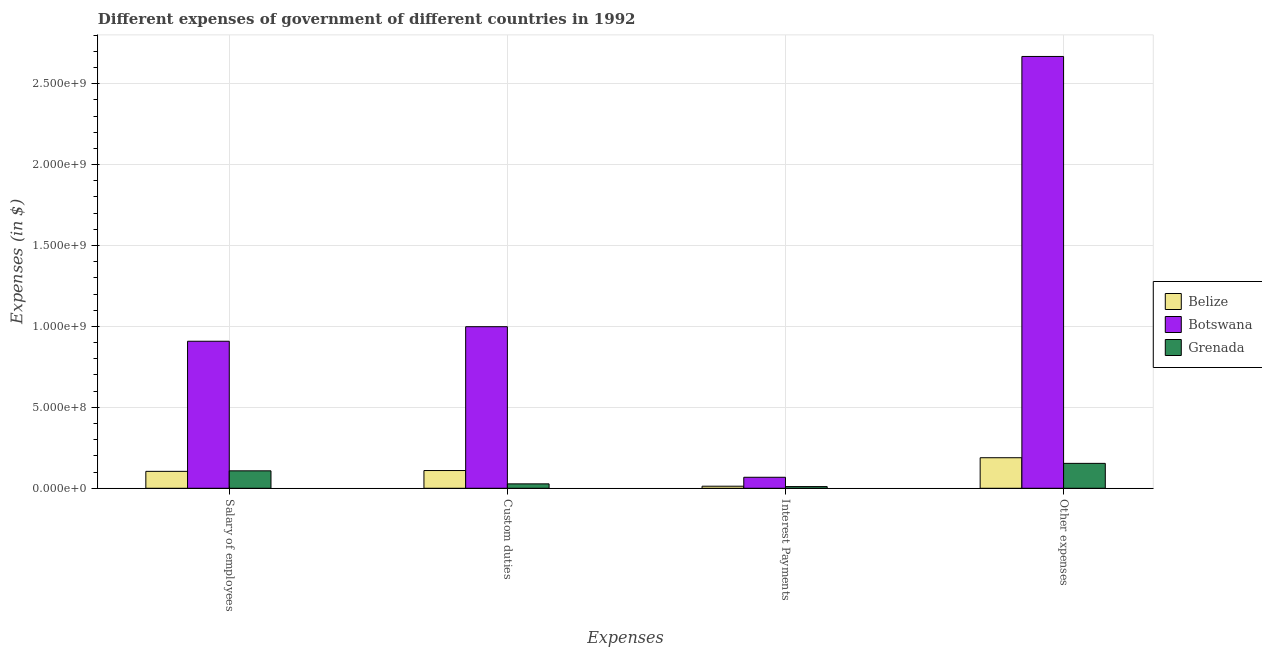How many different coloured bars are there?
Provide a short and direct response. 3. How many groups of bars are there?
Your answer should be compact. 4. How many bars are there on the 2nd tick from the left?
Your answer should be very brief. 3. What is the label of the 3rd group of bars from the left?
Your response must be concise. Interest Payments. What is the amount spent on salary of employees in Belize?
Provide a succinct answer. 1.05e+08. Across all countries, what is the maximum amount spent on custom duties?
Offer a terse response. 9.98e+08. Across all countries, what is the minimum amount spent on other expenses?
Provide a succinct answer. 1.54e+08. In which country was the amount spent on other expenses maximum?
Provide a short and direct response. Botswana. In which country was the amount spent on salary of employees minimum?
Offer a very short reply. Belize. What is the total amount spent on salary of employees in the graph?
Make the answer very short. 1.12e+09. What is the difference between the amount spent on custom duties in Grenada and that in Botswana?
Your answer should be compact. -9.71e+08. What is the difference between the amount spent on custom duties in Botswana and the amount spent on other expenses in Grenada?
Your response must be concise. 8.44e+08. What is the average amount spent on interest payments per country?
Your answer should be very brief. 3.04e+07. What is the difference between the amount spent on custom duties and amount spent on other expenses in Grenada?
Offer a terse response. -1.27e+08. What is the ratio of the amount spent on other expenses in Belize to that in Botswana?
Give a very brief answer. 0.07. Is the amount spent on salary of employees in Botswana less than that in Belize?
Offer a very short reply. No. What is the difference between the highest and the second highest amount spent on custom duties?
Your answer should be compact. 8.89e+08. What is the difference between the highest and the lowest amount spent on salary of employees?
Your answer should be very brief. 8.04e+08. Is the sum of the amount spent on salary of employees in Botswana and Grenada greater than the maximum amount spent on custom duties across all countries?
Your answer should be very brief. Yes. Is it the case that in every country, the sum of the amount spent on custom duties and amount spent on other expenses is greater than the sum of amount spent on interest payments and amount spent on salary of employees?
Your answer should be very brief. No. What does the 1st bar from the left in Custom duties represents?
Provide a short and direct response. Belize. What does the 3rd bar from the right in Custom duties represents?
Keep it short and to the point. Belize. Is it the case that in every country, the sum of the amount spent on salary of employees and amount spent on custom duties is greater than the amount spent on interest payments?
Give a very brief answer. Yes. How many bars are there?
Offer a terse response. 12. What is the difference between two consecutive major ticks on the Y-axis?
Ensure brevity in your answer.  5.00e+08. What is the title of the graph?
Your answer should be compact. Different expenses of government of different countries in 1992. Does "Colombia" appear as one of the legend labels in the graph?
Give a very brief answer. No. What is the label or title of the X-axis?
Make the answer very short. Expenses. What is the label or title of the Y-axis?
Provide a succinct answer. Expenses (in $). What is the Expenses (in $) in Belize in Salary of employees?
Keep it short and to the point. 1.05e+08. What is the Expenses (in $) of Botswana in Salary of employees?
Offer a very short reply. 9.08e+08. What is the Expenses (in $) in Grenada in Salary of employees?
Give a very brief answer. 1.08e+08. What is the Expenses (in $) of Belize in Custom duties?
Give a very brief answer. 1.10e+08. What is the Expenses (in $) in Botswana in Custom duties?
Your answer should be very brief. 9.98e+08. What is the Expenses (in $) of Grenada in Custom duties?
Ensure brevity in your answer.  2.73e+07. What is the Expenses (in $) of Belize in Interest Payments?
Provide a succinct answer. 1.28e+07. What is the Expenses (in $) of Botswana in Interest Payments?
Your response must be concise. 6.80e+07. What is the Expenses (in $) in Grenada in Interest Payments?
Give a very brief answer. 1.04e+07. What is the Expenses (in $) of Belize in Other expenses?
Offer a very short reply. 1.89e+08. What is the Expenses (in $) of Botswana in Other expenses?
Offer a terse response. 2.67e+09. What is the Expenses (in $) of Grenada in Other expenses?
Offer a very short reply. 1.54e+08. Across all Expenses, what is the maximum Expenses (in $) of Belize?
Make the answer very short. 1.89e+08. Across all Expenses, what is the maximum Expenses (in $) in Botswana?
Offer a terse response. 2.67e+09. Across all Expenses, what is the maximum Expenses (in $) in Grenada?
Provide a succinct answer. 1.54e+08. Across all Expenses, what is the minimum Expenses (in $) of Belize?
Offer a very short reply. 1.28e+07. Across all Expenses, what is the minimum Expenses (in $) of Botswana?
Ensure brevity in your answer.  6.80e+07. Across all Expenses, what is the minimum Expenses (in $) in Grenada?
Give a very brief answer. 1.04e+07. What is the total Expenses (in $) of Belize in the graph?
Provide a short and direct response. 4.16e+08. What is the total Expenses (in $) in Botswana in the graph?
Offer a terse response. 4.64e+09. What is the total Expenses (in $) of Grenada in the graph?
Provide a succinct answer. 3.00e+08. What is the difference between the Expenses (in $) of Belize in Salary of employees and that in Custom duties?
Make the answer very short. -4.97e+06. What is the difference between the Expenses (in $) of Botswana in Salary of employees and that in Custom duties?
Provide a succinct answer. -8.99e+07. What is the difference between the Expenses (in $) in Grenada in Salary of employees and that in Custom duties?
Your answer should be very brief. 8.05e+07. What is the difference between the Expenses (in $) of Belize in Salary of employees and that in Interest Payments?
Provide a short and direct response. 9.19e+07. What is the difference between the Expenses (in $) in Botswana in Salary of employees and that in Interest Payments?
Make the answer very short. 8.40e+08. What is the difference between the Expenses (in $) in Grenada in Salary of employees and that in Interest Payments?
Offer a terse response. 9.74e+07. What is the difference between the Expenses (in $) of Belize in Salary of employees and that in Other expenses?
Offer a very short reply. -8.41e+07. What is the difference between the Expenses (in $) in Botswana in Salary of employees and that in Other expenses?
Ensure brevity in your answer.  -1.76e+09. What is the difference between the Expenses (in $) in Grenada in Salary of employees and that in Other expenses?
Your response must be concise. -4.62e+07. What is the difference between the Expenses (in $) in Belize in Custom duties and that in Interest Payments?
Ensure brevity in your answer.  9.68e+07. What is the difference between the Expenses (in $) of Botswana in Custom duties and that in Interest Payments?
Offer a very short reply. 9.30e+08. What is the difference between the Expenses (in $) in Grenada in Custom duties and that in Interest Payments?
Your response must be concise. 1.68e+07. What is the difference between the Expenses (in $) in Belize in Custom duties and that in Other expenses?
Offer a very short reply. -7.92e+07. What is the difference between the Expenses (in $) in Botswana in Custom duties and that in Other expenses?
Offer a terse response. -1.67e+09. What is the difference between the Expenses (in $) in Grenada in Custom duties and that in Other expenses?
Your answer should be compact. -1.27e+08. What is the difference between the Expenses (in $) of Belize in Interest Payments and that in Other expenses?
Provide a short and direct response. -1.76e+08. What is the difference between the Expenses (in $) in Botswana in Interest Payments and that in Other expenses?
Keep it short and to the point. -2.60e+09. What is the difference between the Expenses (in $) of Grenada in Interest Payments and that in Other expenses?
Your answer should be very brief. -1.44e+08. What is the difference between the Expenses (in $) in Belize in Salary of employees and the Expenses (in $) in Botswana in Custom duties?
Keep it short and to the point. -8.94e+08. What is the difference between the Expenses (in $) of Belize in Salary of employees and the Expenses (in $) of Grenada in Custom duties?
Offer a terse response. 7.73e+07. What is the difference between the Expenses (in $) in Botswana in Salary of employees and the Expenses (in $) in Grenada in Custom duties?
Offer a terse response. 8.81e+08. What is the difference between the Expenses (in $) in Belize in Salary of employees and the Expenses (in $) in Botswana in Interest Payments?
Your response must be concise. 3.66e+07. What is the difference between the Expenses (in $) of Belize in Salary of employees and the Expenses (in $) of Grenada in Interest Payments?
Ensure brevity in your answer.  9.42e+07. What is the difference between the Expenses (in $) of Botswana in Salary of employees and the Expenses (in $) of Grenada in Interest Payments?
Provide a short and direct response. 8.98e+08. What is the difference between the Expenses (in $) in Belize in Salary of employees and the Expenses (in $) in Botswana in Other expenses?
Make the answer very short. -2.56e+09. What is the difference between the Expenses (in $) of Belize in Salary of employees and the Expenses (in $) of Grenada in Other expenses?
Provide a short and direct response. -4.94e+07. What is the difference between the Expenses (in $) in Botswana in Salary of employees and the Expenses (in $) in Grenada in Other expenses?
Make the answer very short. 7.55e+08. What is the difference between the Expenses (in $) of Belize in Custom duties and the Expenses (in $) of Botswana in Interest Payments?
Offer a terse response. 4.16e+07. What is the difference between the Expenses (in $) in Belize in Custom duties and the Expenses (in $) in Grenada in Interest Payments?
Ensure brevity in your answer.  9.91e+07. What is the difference between the Expenses (in $) in Botswana in Custom duties and the Expenses (in $) in Grenada in Interest Payments?
Offer a terse response. 9.88e+08. What is the difference between the Expenses (in $) of Belize in Custom duties and the Expenses (in $) of Botswana in Other expenses?
Give a very brief answer. -2.56e+09. What is the difference between the Expenses (in $) of Belize in Custom duties and the Expenses (in $) of Grenada in Other expenses?
Provide a short and direct response. -4.44e+07. What is the difference between the Expenses (in $) in Botswana in Custom duties and the Expenses (in $) in Grenada in Other expenses?
Your answer should be very brief. 8.44e+08. What is the difference between the Expenses (in $) of Belize in Interest Payments and the Expenses (in $) of Botswana in Other expenses?
Your response must be concise. -2.66e+09. What is the difference between the Expenses (in $) of Belize in Interest Payments and the Expenses (in $) of Grenada in Other expenses?
Your response must be concise. -1.41e+08. What is the difference between the Expenses (in $) in Botswana in Interest Payments and the Expenses (in $) in Grenada in Other expenses?
Offer a terse response. -8.60e+07. What is the average Expenses (in $) in Belize per Expenses?
Ensure brevity in your answer.  1.04e+08. What is the average Expenses (in $) in Botswana per Expenses?
Offer a very short reply. 1.16e+09. What is the average Expenses (in $) of Grenada per Expenses?
Your answer should be very brief. 7.49e+07. What is the difference between the Expenses (in $) in Belize and Expenses (in $) in Botswana in Salary of employees?
Your answer should be compact. -8.04e+08. What is the difference between the Expenses (in $) in Belize and Expenses (in $) in Grenada in Salary of employees?
Make the answer very short. -3.19e+06. What is the difference between the Expenses (in $) in Botswana and Expenses (in $) in Grenada in Salary of employees?
Provide a short and direct response. 8.01e+08. What is the difference between the Expenses (in $) in Belize and Expenses (in $) in Botswana in Custom duties?
Your response must be concise. -8.89e+08. What is the difference between the Expenses (in $) in Belize and Expenses (in $) in Grenada in Custom duties?
Provide a succinct answer. 8.23e+07. What is the difference between the Expenses (in $) of Botswana and Expenses (in $) of Grenada in Custom duties?
Provide a succinct answer. 9.71e+08. What is the difference between the Expenses (in $) of Belize and Expenses (in $) of Botswana in Interest Payments?
Provide a short and direct response. -5.52e+07. What is the difference between the Expenses (in $) of Belize and Expenses (in $) of Grenada in Interest Payments?
Provide a short and direct response. 2.31e+06. What is the difference between the Expenses (in $) of Botswana and Expenses (in $) of Grenada in Interest Payments?
Give a very brief answer. 5.76e+07. What is the difference between the Expenses (in $) in Belize and Expenses (in $) in Botswana in Other expenses?
Your answer should be compact. -2.48e+09. What is the difference between the Expenses (in $) in Belize and Expenses (in $) in Grenada in Other expenses?
Make the answer very short. 3.48e+07. What is the difference between the Expenses (in $) in Botswana and Expenses (in $) in Grenada in Other expenses?
Keep it short and to the point. 2.51e+09. What is the ratio of the Expenses (in $) in Belize in Salary of employees to that in Custom duties?
Offer a terse response. 0.95. What is the ratio of the Expenses (in $) of Botswana in Salary of employees to that in Custom duties?
Your response must be concise. 0.91. What is the ratio of the Expenses (in $) of Grenada in Salary of employees to that in Custom duties?
Keep it short and to the point. 3.95. What is the ratio of the Expenses (in $) in Belize in Salary of employees to that in Interest Payments?
Your answer should be compact. 8.2. What is the ratio of the Expenses (in $) in Botswana in Salary of employees to that in Interest Payments?
Give a very brief answer. 13.36. What is the ratio of the Expenses (in $) in Grenada in Salary of employees to that in Interest Payments?
Offer a very short reply. 10.33. What is the ratio of the Expenses (in $) of Belize in Salary of employees to that in Other expenses?
Your answer should be compact. 0.55. What is the ratio of the Expenses (in $) in Botswana in Salary of employees to that in Other expenses?
Make the answer very short. 0.34. What is the ratio of the Expenses (in $) of Grenada in Salary of employees to that in Other expenses?
Offer a terse response. 0.7. What is the ratio of the Expenses (in $) of Belize in Custom duties to that in Interest Payments?
Your response must be concise. 8.59. What is the ratio of the Expenses (in $) of Botswana in Custom duties to that in Interest Payments?
Provide a short and direct response. 14.68. What is the ratio of the Expenses (in $) of Grenada in Custom duties to that in Interest Payments?
Offer a very short reply. 2.61. What is the ratio of the Expenses (in $) of Belize in Custom duties to that in Other expenses?
Your response must be concise. 0.58. What is the ratio of the Expenses (in $) of Botswana in Custom duties to that in Other expenses?
Provide a short and direct response. 0.37. What is the ratio of the Expenses (in $) of Grenada in Custom duties to that in Other expenses?
Provide a short and direct response. 0.18. What is the ratio of the Expenses (in $) in Belize in Interest Payments to that in Other expenses?
Provide a succinct answer. 0.07. What is the ratio of the Expenses (in $) of Botswana in Interest Payments to that in Other expenses?
Offer a terse response. 0.03. What is the ratio of the Expenses (in $) in Grenada in Interest Payments to that in Other expenses?
Your answer should be compact. 0.07. What is the difference between the highest and the second highest Expenses (in $) of Belize?
Give a very brief answer. 7.92e+07. What is the difference between the highest and the second highest Expenses (in $) of Botswana?
Offer a terse response. 1.67e+09. What is the difference between the highest and the second highest Expenses (in $) of Grenada?
Give a very brief answer. 4.62e+07. What is the difference between the highest and the lowest Expenses (in $) in Belize?
Your response must be concise. 1.76e+08. What is the difference between the highest and the lowest Expenses (in $) in Botswana?
Make the answer very short. 2.60e+09. What is the difference between the highest and the lowest Expenses (in $) of Grenada?
Offer a terse response. 1.44e+08. 